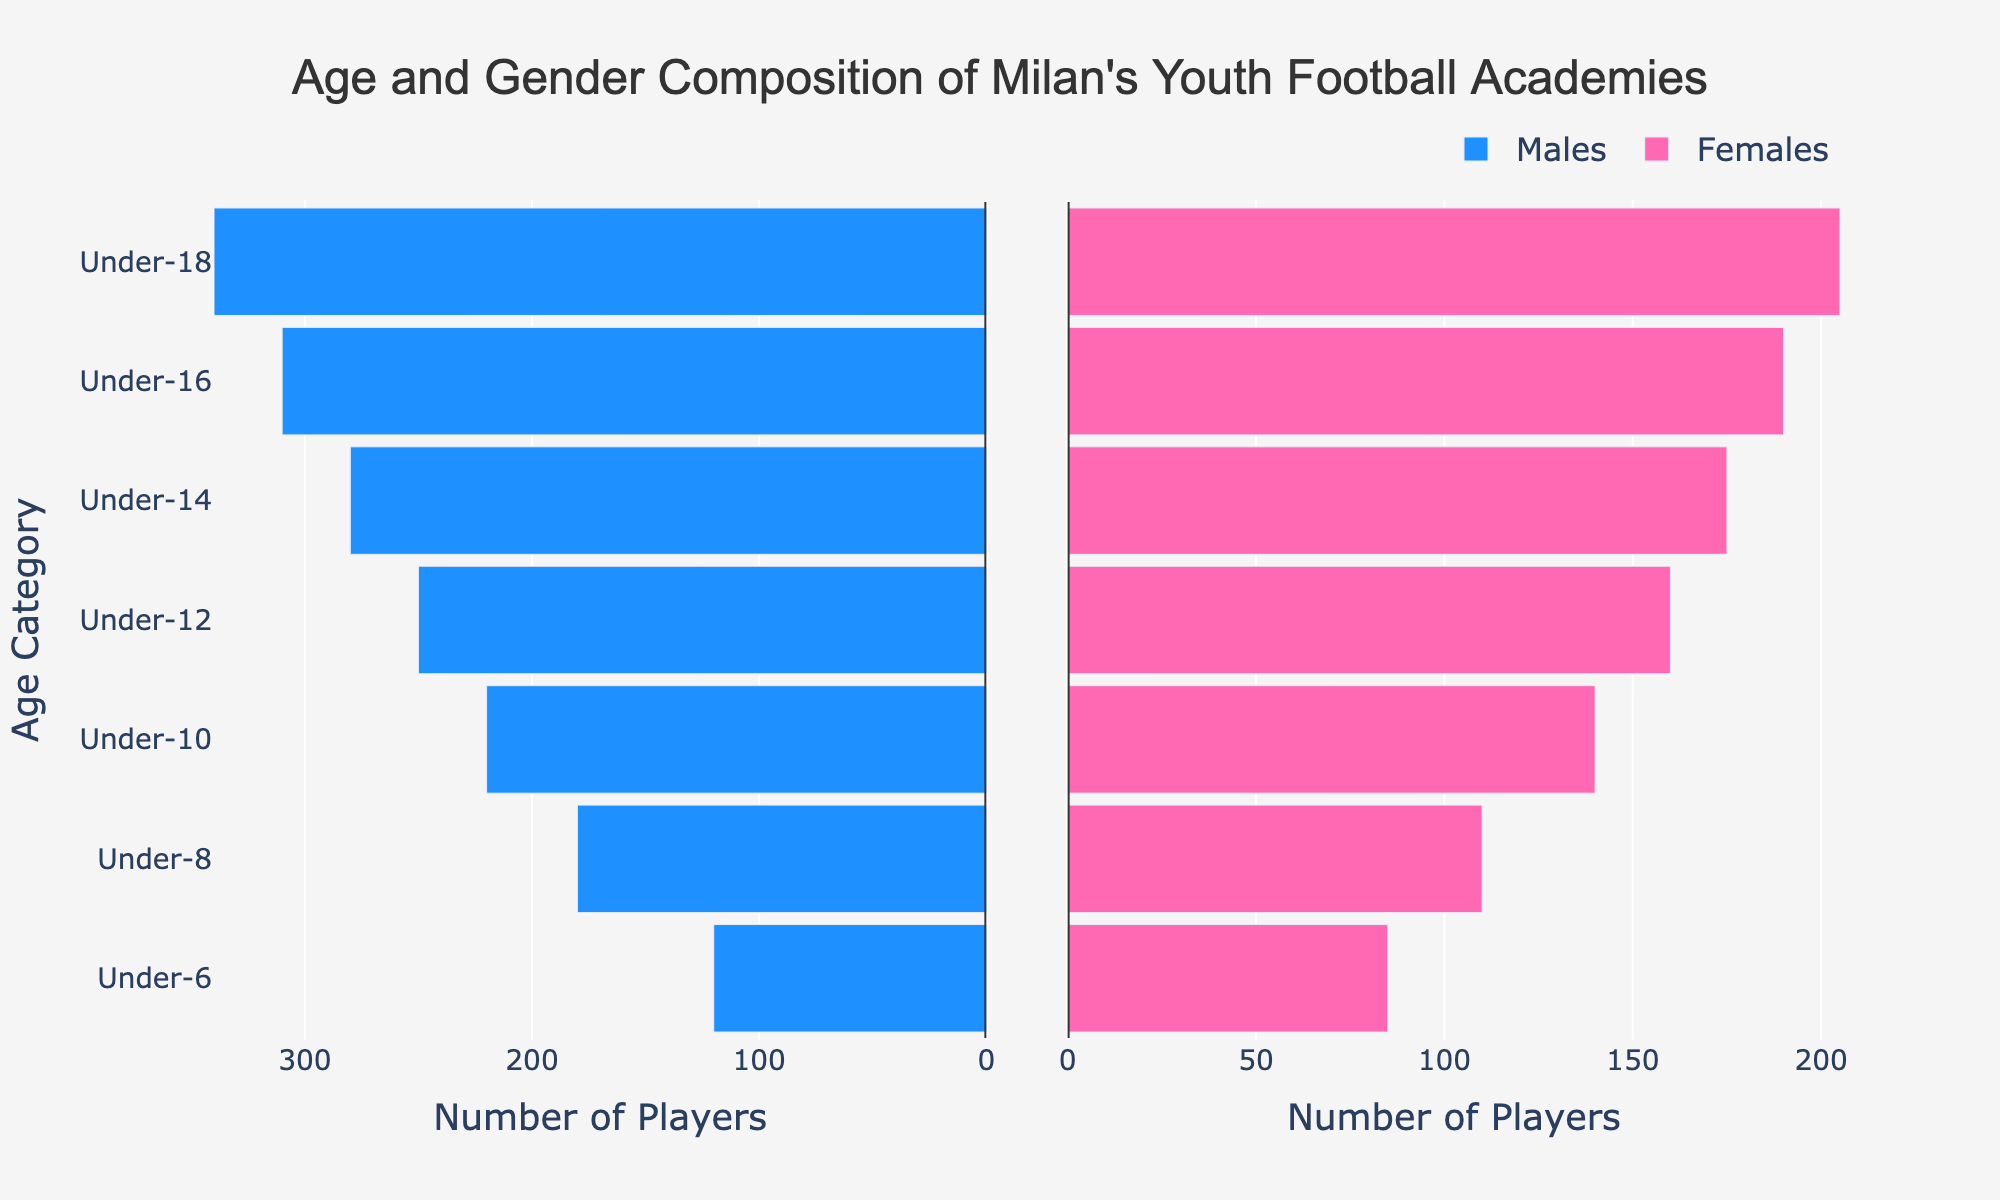How many players are there in the Under-12 category? There are 250 male players and 160 female players. Adding them together gives 250 + 160 = 410.
Answer: 410 Which age category has the highest number of male players? By looking at the plot, Under-18 category has the highest number of male players, with 340.
Answer: Under-18 What is the difference in the number of female players between the Under-6 and Under-18 categories? The Under-6 category has 85 female players and the Under-18 category has 205. The difference is 205 - 85 = 120.
Answer: 120 Are there more male or female players in the Under-16 category? In the Under-16 category, there are 310 male players and 190 female players. Since 310 > 190, there are more male players.
Answer: Male players Which age category has the smallest number of players in total? The Under-6 category has 120 male players and 85 female players. Adding them together gives 120 + 85 = 205. This is the smallest total number among all categories.
Answer: Under-6 How does the total number of players change as the age category increases from Under-6 to Under-18? The total number of players in each age category increases as the age category increases, starting from 205 in Under-6 and reaching 545 in Under-18.
Answer: Increases Among the under-14 and under-16 categories, which has the higher number of female players and by how much? The Under-14 category has 175 female players, and the Under-16 category has 190 female players. The difference is 190 - 175 = 15.
Answer: Under-16, 15 Do male or female players show a larger increase in numbers from the Under-10 to Under-18 categories? Male players increase from 220 (Under-10) to 340 (Under-18), an increase of 340 - 220 = 120. Female players increase from 140 (Under-10) to 205 (Under-18), an increase of 205 - 140 = 65. So, males show a larger increase.
Answer: Male players Which age category has the highest total number of players and what is that total? The Under-18 category has the highest total number of players. Adding 340 male players and 205 female players gives 340 + 205 = 545.
Answer: Under-18, 545 Is the distribution between male and female players more balanced in younger or older categories? In younger categories like Under-6, the distributions are relatively closer (120 males to 85 females), while in older categories like Under-18, the gap widens (340 males to 205 females). Therefore, the distribution is more balanced in younger categories.
Answer: Younger categories 